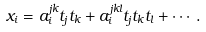Convert formula to latex. <formula><loc_0><loc_0><loc_500><loc_500>x _ { i } = a ^ { j k } _ { i } t _ { j } t _ { k } + a ^ { j k l } _ { i } t _ { j } t _ { k } t _ { l } + \cdots .</formula> 